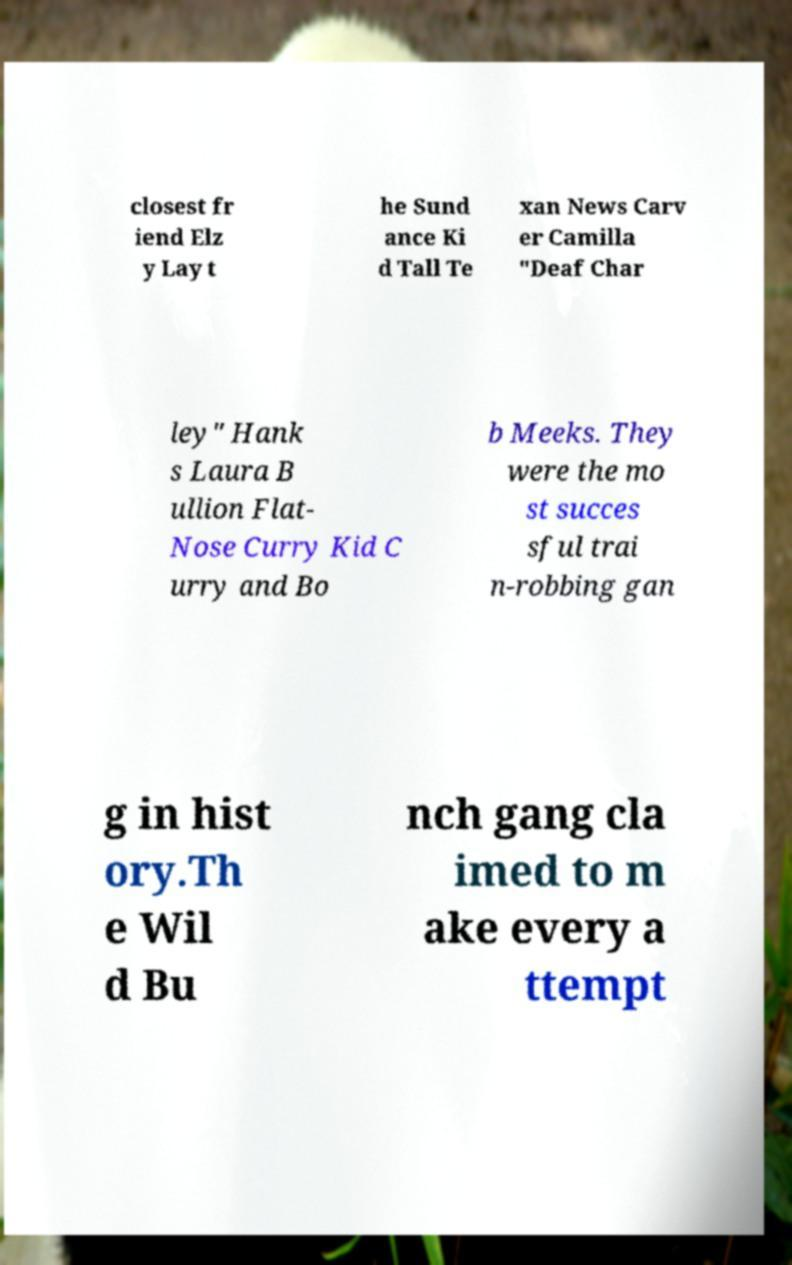What messages or text are displayed in this image? I need them in a readable, typed format. closest fr iend Elz y Lay t he Sund ance Ki d Tall Te xan News Carv er Camilla "Deaf Char ley" Hank s Laura B ullion Flat- Nose Curry Kid C urry and Bo b Meeks. They were the mo st succes sful trai n-robbing gan g in hist ory.Th e Wil d Bu nch gang cla imed to m ake every a ttempt 